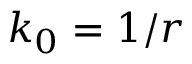<formula> <loc_0><loc_0><loc_500><loc_500>k _ { 0 } = 1 / r</formula> 